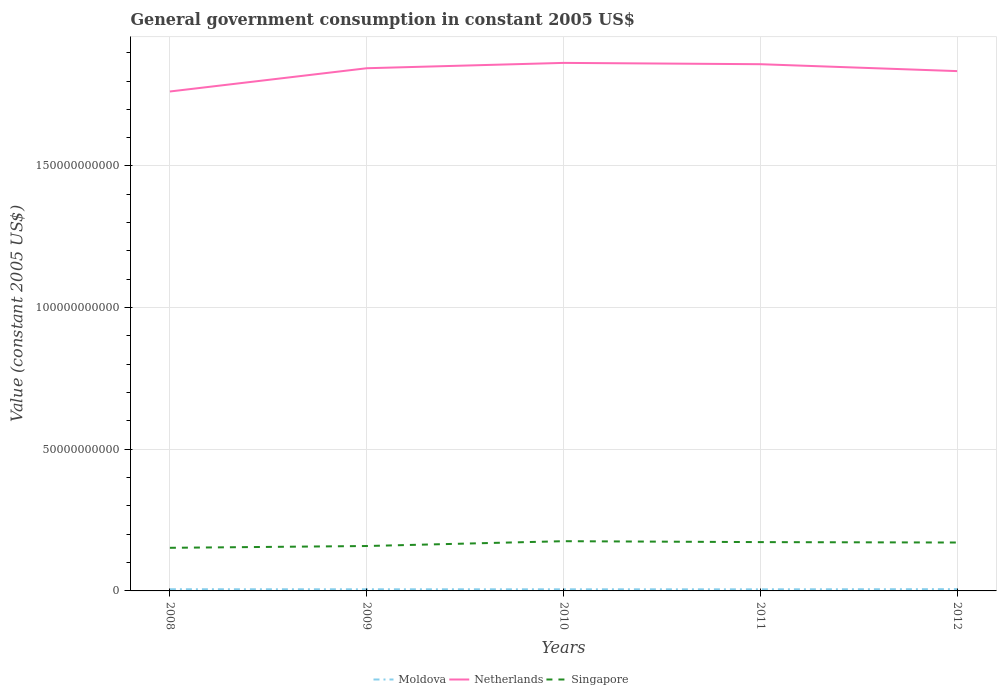Does the line corresponding to Singapore intersect with the line corresponding to Netherlands?
Your response must be concise. No. Across all years, what is the maximum government conusmption in Singapore?
Provide a short and direct response. 1.52e+1. In which year was the government conusmption in Netherlands maximum?
Provide a succinct answer. 2008. What is the total government conusmption in Netherlands in the graph?
Your answer should be compact. -1.42e+09. What is the difference between the highest and the second highest government conusmption in Singapore?
Your response must be concise. 2.34e+09. Are the values on the major ticks of Y-axis written in scientific E-notation?
Make the answer very short. No. Where does the legend appear in the graph?
Give a very brief answer. Bottom center. What is the title of the graph?
Offer a terse response. General government consumption in constant 2005 US$. Does "Costa Rica" appear as one of the legend labels in the graph?
Your answer should be very brief. No. What is the label or title of the X-axis?
Make the answer very short. Years. What is the label or title of the Y-axis?
Provide a succinct answer. Value (constant 2005 US$). What is the Value (constant 2005 US$) of Moldova in 2008?
Make the answer very short. 5.97e+08. What is the Value (constant 2005 US$) of Netherlands in 2008?
Ensure brevity in your answer.  1.76e+11. What is the Value (constant 2005 US$) of Singapore in 2008?
Give a very brief answer. 1.52e+1. What is the Value (constant 2005 US$) in Moldova in 2009?
Offer a terse response. 5.80e+08. What is the Value (constant 2005 US$) of Netherlands in 2009?
Your answer should be compact. 1.85e+11. What is the Value (constant 2005 US$) of Singapore in 2009?
Give a very brief answer. 1.59e+1. What is the Value (constant 2005 US$) in Moldova in 2010?
Your answer should be compact. 5.74e+08. What is the Value (constant 2005 US$) of Netherlands in 2010?
Your answer should be very brief. 1.86e+11. What is the Value (constant 2005 US$) of Singapore in 2010?
Your answer should be compact. 1.76e+1. What is the Value (constant 2005 US$) in Moldova in 2011?
Keep it short and to the point. 5.68e+08. What is the Value (constant 2005 US$) of Netherlands in 2011?
Offer a very short reply. 1.86e+11. What is the Value (constant 2005 US$) in Singapore in 2011?
Provide a short and direct response. 1.72e+1. What is the Value (constant 2005 US$) in Moldova in 2012?
Provide a succinct answer. 6.22e+08. What is the Value (constant 2005 US$) in Netherlands in 2012?
Make the answer very short. 1.83e+11. What is the Value (constant 2005 US$) in Singapore in 2012?
Your response must be concise. 1.71e+1. Across all years, what is the maximum Value (constant 2005 US$) in Moldova?
Give a very brief answer. 6.22e+08. Across all years, what is the maximum Value (constant 2005 US$) in Netherlands?
Your response must be concise. 1.86e+11. Across all years, what is the maximum Value (constant 2005 US$) of Singapore?
Offer a terse response. 1.76e+1. Across all years, what is the minimum Value (constant 2005 US$) of Moldova?
Provide a short and direct response. 5.68e+08. Across all years, what is the minimum Value (constant 2005 US$) of Netherlands?
Keep it short and to the point. 1.76e+11. Across all years, what is the minimum Value (constant 2005 US$) of Singapore?
Offer a terse response. 1.52e+1. What is the total Value (constant 2005 US$) of Moldova in the graph?
Your answer should be very brief. 2.94e+09. What is the total Value (constant 2005 US$) of Netherlands in the graph?
Your answer should be very brief. 9.17e+11. What is the total Value (constant 2005 US$) of Singapore in the graph?
Your response must be concise. 8.29e+1. What is the difference between the Value (constant 2005 US$) of Moldova in 2008 and that in 2009?
Your answer should be very brief. 1.71e+07. What is the difference between the Value (constant 2005 US$) of Netherlands in 2008 and that in 2009?
Make the answer very short. -8.21e+09. What is the difference between the Value (constant 2005 US$) of Singapore in 2008 and that in 2009?
Keep it short and to the point. -6.35e+08. What is the difference between the Value (constant 2005 US$) in Moldova in 2008 and that in 2010?
Your answer should be very brief. 2.33e+07. What is the difference between the Value (constant 2005 US$) in Netherlands in 2008 and that in 2010?
Your answer should be compact. -1.01e+1. What is the difference between the Value (constant 2005 US$) in Singapore in 2008 and that in 2010?
Keep it short and to the point. -2.34e+09. What is the difference between the Value (constant 2005 US$) of Moldova in 2008 and that in 2011?
Your response must be concise. 2.89e+07. What is the difference between the Value (constant 2005 US$) in Netherlands in 2008 and that in 2011?
Offer a very short reply. -9.63e+09. What is the difference between the Value (constant 2005 US$) of Singapore in 2008 and that in 2011?
Give a very brief answer. -2.01e+09. What is the difference between the Value (constant 2005 US$) of Moldova in 2008 and that in 2012?
Keep it short and to the point. -2.47e+07. What is the difference between the Value (constant 2005 US$) in Netherlands in 2008 and that in 2012?
Keep it short and to the point. -7.19e+09. What is the difference between the Value (constant 2005 US$) in Singapore in 2008 and that in 2012?
Keep it short and to the point. -1.87e+09. What is the difference between the Value (constant 2005 US$) of Moldova in 2009 and that in 2010?
Your answer should be compact. 6.27e+06. What is the difference between the Value (constant 2005 US$) in Netherlands in 2009 and that in 2010?
Provide a succinct answer. -1.89e+09. What is the difference between the Value (constant 2005 US$) in Singapore in 2009 and that in 2010?
Ensure brevity in your answer.  -1.70e+09. What is the difference between the Value (constant 2005 US$) in Moldova in 2009 and that in 2011?
Ensure brevity in your answer.  1.18e+07. What is the difference between the Value (constant 2005 US$) of Netherlands in 2009 and that in 2011?
Provide a succinct answer. -1.42e+09. What is the difference between the Value (constant 2005 US$) in Singapore in 2009 and that in 2011?
Give a very brief answer. -1.38e+09. What is the difference between the Value (constant 2005 US$) of Moldova in 2009 and that in 2012?
Your answer should be compact. -4.18e+07. What is the difference between the Value (constant 2005 US$) of Netherlands in 2009 and that in 2012?
Ensure brevity in your answer.  1.02e+09. What is the difference between the Value (constant 2005 US$) in Singapore in 2009 and that in 2012?
Make the answer very short. -1.23e+09. What is the difference between the Value (constant 2005 US$) in Moldova in 2010 and that in 2011?
Offer a very short reply. 5.57e+06. What is the difference between the Value (constant 2005 US$) in Netherlands in 2010 and that in 2011?
Provide a succinct answer. 4.61e+08. What is the difference between the Value (constant 2005 US$) of Singapore in 2010 and that in 2011?
Ensure brevity in your answer.  3.23e+08. What is the difference between the Value (constant 2005 US$) in Moldova in 2010 and that in 2012?
Provide a short and direct response. -4.81e+07. What is the difference between the Value (constant 2005 US$) of Netherlands in 2010 and that in 2012?
Your response must be concise. 2.90e+09. What is the difference between the Value (constant 2005 US$) of Singapore in 2010 and that in 2012?
Provide a succinct answer. 4.70e+08. What is the difference between the Value (constant 2005 US$) of Moldova in 2011 and that in 2012?
Provide a succinct answer. -5.37e+07. What is the difference between the Value (constant 2005 US$) of Netherlands in 2011 and that in 2012?
Make the answer very short. 2.44e+09. What is the difference between the Value (constant 2005 US$) in Singapore in 2011 and that in 2012?
Keep it short and to the point. 1.47e+08. What is the difference between the Value (constant 2005 US$) in Moldova in 2008 and the Value (constant 2005 US$) in Netherlands in 2009?
Your answer should be compact. -1.84e+11. What is the difference between the Value (constant 2005 US$) of Moldova in 2008 and the Value (constant 2005 US$) of Singapore in 2009?
Provide a short and direct response. -1.53e+1. What is the difference between the Value (constant 2005 US$) of Netherlands in 2008 and the Value (constant 2005 US$) of Singapore in 2009?
Offer a very short reply. 1.60e+11. What is the difference between the Value (constant 2005 US$) in Moldova in 2008 and the Value (constant 2005 US$) in Netherlands in 2010?
Give a very brief answer. -1.86e+11. What is the difference between the Value (constant 2005 US$) in Moldova in 2008 and the Value (constant 2005 US$) in Singapore in 2010?
Offer a very short reply. -1.70e+1. What is the difference between the Value (constant 2005 US$) in Netherlands in 2008 and the Value (constant 2005 US$) in Singapore in 2010?
Your response must be concise. 1.59e+11. What is the difference between the Value (constant 2005 US$) in Moldova in 2008 and the Value (constant 2005 US$) in Netherlands in 2011?
Give a very brief answer. -1.85e+11. What is the difference between the Value (constant 2005 US$) of Moldova in 2008 and the Value (constant 2005 US$) of Singapore in 2011?
Your response must be concise. -1.66e+1. What is the difference between the Value (constant 2005 US$) in Netherlands in 2008 and the Value (constant 2005 US$) in Singapore in 2011?
Make the answer very short. 1.59e+11. What is the difference between the Value (constant 2005 US$) of Moldova in 2008 and the Value (constant 2005 US$) of Netherlands in 2012?
Keep it short and to the point. -1.83e+11. What is the difference between the Value (constant 2005 US$) of Moldova in 2008 and the Value (constant 2005 US$) of Singapore in 2012?
Make the answer very short. -1.65e+1. What is the difference between the Value (constant 2005 US$) in Netherlands in 2008 and the Value (constant 2005 US$) in Singapore in 2012?
Offer a terse response. 1.59e+11. What is the difference between the Value (constant 2005 US$) in Moldova in 2009 and the Value (constant 2005 US$) in Netherlands in 2010?
Ensure brevity in your answer.  -1.86e+11. What is the difference between the Value (constant 2005 US$) in Moldova in 2009 and the Value (constant 2005 US$) in Singapore in 2010?
Keep it short and to the point. -1.70e+1. What is the difference between the Value (constant 2005 US$) in Netherlands in 2009 and the Value (constant 2005 US$) in Singapore in 2010?
Provide a succinct answer. 1.67e+11. What is the difference between the Value (constant 2005 US$) in Moldova in 2009 and the Value (constant 2005 US$) in Netherlands in 2011?
Provide a short and direct response. -1.85e+11. What is the difference between the Value (constant 2005 US$) of Moldova in 2009 and the Value (constant 2005 US$) of Singapore in 2011?
Provide a succinct answer. -1.67e+1. What is the difference between the Value (constant 2005 US$) of Netherlands in 2009 and the Value (constant 2005 US$) of Singapore in 2011?
Make the answer very short. 1.67e+11. What is the difference between the Value (constant 2005 US$) in Moldova in 2009 and the Value (constant 2005 US$) in Netherlands in 2012?
Provide a short and direct response. -1.83e+11. What is the difference between the Value (constant 2005 US$) in Moldova in 2009 and the Value (constant 2005 US$) in Singapore in 2012?
Ensure brevity in your answer.  -1.65e+1. What is the difference between the Value (constant 2005 US$) in Netherlands in 2009 and the Value (constant 2005 US$) in Singapore in 2012?
Make the answer very short. 1.67e+11. What is the difference between the Value (constant 2005 US$) of Moldova in 2010 and the Value (constant 2005 US$) of Netherlands in 2011?
Your answer should be very brief. -1.85e+11. What is the difference between the Value (constant 2005 US$) of Moldova in 2010 and the Value (constant 2005 US$) of Singapore in 2011?
Give a very brief answer. -1.67e+1. What is the difference between the Value (constant 2005 US$) of Netherlands in 2010 and the Value (constant 2005 US$) of Singapore in 2011?
Offer a terse response. 1.69e+11. What is the difference between the Value (constant 2005 US$) in Moldova in 2010 and the Value (constant 2005 US$) in Netherlands in 2012?
Your answer should be very brief. -1.83e+11. What is the difference between the Value (constant 2005 US$) in Moldova in 2010 and the Value (constant 2005 US$) in Singapore in 2012?
Make the answer very short. -1.65e+1. What is the difference between the Value (constant 2005 US$) in Netherlands in 2010 and the Value (constant 2005 US$) in Singapore in 2012?
Ensure brevity in your answer.  1.69e+11. What is the difference between the Value (constant 2005 US$) in Moldova in 2011 and the Value (constant 2005 US$) in Netherlands in 2012?
Offer a very short reply. -1.83e+11. What is the difference between the Value (constant 2005 US$) of Moldova in 2011 and the Value (constant 2005 US$) of Singapore in 2012?
Give a very brief answer. -1.65e+1. What is the difference between the Value (constant 2005 US$) in Netherlands in 2011 and the Value (constant 2005 US$) in Singapore in 2012?
Provide a short and direct response. 1.69e+11. What is the average Value (constant 2005 US$) in Moldova per year?
Keep it short and to the point. 5.88e+08. What is the average Value (constant 2005 US$) of Netherlands per year?
Give a very brief answer. 1.83e+11. What is the average Value (constant 2005 US$) in Singapore per year?
Keep it short and to the point. 1.66e+1. In the year 2008, what is the difference between the Value (constant 2005 US$) of Moldova and Value (constant 2005 US$) of Netherlands?
Ensure brevity in your answer.  -1.76e+11. In the year 2008, what is the difference between the Value (constant 2005 US$) of Moldova and Value (constant 2005 US$) of Singapore?
Ensure brevity in your answer.  -1.46e+1. In the year 2008, what is the difference between the Value (constant 2005 US$) of Netherlands and Value (constant 2005 US$) of Singapore?
Your response must be concise. 1.61e+11. In the year 2009, what is the difference between the Value (constant 2005 US$) of Moldova and Value (constant 2005 US$) of Netherlands?
Give a very brief answer. -1.84e+11. In the year 2009, what is the difference between the Value (constant 2005 US$) of Moldova and Value (constant 2005 US$) of Singapore?
Make the answer very short. -1.53e+1. In the year 2009, what is the difference between the Value (constant 2005 US$) of Netherlands and Value (constant 2005 US$) of Singapore?
Provide a succinct answer. 1.69e+11. In the year 2010, what is the difference between the Value (constant 2005 US$) of Moldova and Value (constant 2005 US$) of Netherlands?
Make the answer very short. -1.86e+11. In the year 2010, what is the difference between the Value (constant 2005 US$) of Moldova and Value (constant 2005 US$) of Singapore?
Your answer should be compact. -1.70e+1. In the year 2010, what is the difference between the Value (constant 2005 US$) in Netherlands and Value (constant 2005 US$) in Singapore?
Your response must be concise. 1.69e+11. In the year 2011, what is the difference between the Value (constant 2005 US$) of Moldova and Value (constant 2005 US$) of Netherlands?
Make the answer very short. -1.85e+11. In the year 2011, what is the difference between the Value (constant 2005 US$) of Moldova and Value (constant 2005 US$) of Singapore?
Offer a very short reply. -1.67e+1. In the year 2011, what is the difference between the Value (constant 2005 US$) in Netherlands and Value (constant 2005 US$) in Singapore?
Provide a succinct answer. 1.69e+11. In the year 2012, what is the difference between the Value (constant 2005 US$) of Moldova and Value (constant 2005 US$) of Netherlands?
Your answer should be very brief. -1.83e+11. In the year 2012, what is the difference between the Value (constant 2005 US$) in Moldova and Value (constant 2005 US$) in Singapore?
Provide a short and direct response. -1.65e+1. In the year 2012, what is the difference between the Value (constant 2005 US$) in Netherlands and Value (constant 2005 US$) in Singapore?
Provide a succinct answer. 1.66e+11. What is the ratio of the Value (constant 2005 US$) in Moldova in 2008 to that in 2009?
Your response must be concise. 1.03. What is the ratio of the Value (constant 2005 US$) in Netherlands in 2008 to that in 2009?
Make the answer very short. 0.96. What is the ratio of the Value (constant 2005 US$) in Moldova in 2008 to that in 2010?
Provide a succinct answer. 1.04. What is the ratio of the Value (constant 2005 US$) in Netherlands in 2008 to that in 2010?
Keep it short and to the point. 0.95. What is the ratio of the Value (constant 2005 US$) of Singapore in 2008 to that in 2010?
Your answer should be very brief. 0.87. What is the ratio of the Value (constant 2005 US$) of Moldova in 2008 to that in 2011?
Ensure brevity in your answer.  1.05. What is the ratio of the Value (constant 2005 US$) of Netherlands in 2008 to that in 2011?
Your answer should be very brief. 0.95. What is the ratio of the Value (constant 2005 US$) of Singapore in 2008 to that in 2011?
Give a very brief answer. 0.88. What is the ratio of the Value (constant 2005 US$) of Moldova in 2008 to that in 2012?
Make the answer very short. 0.96. What is the ratio of the Value (constant 2005 US$) of Netherlands in 2008 to that in 2012?
Your answer should be compact. 0.96. What is the ratio of the Value (constant 2005 US$) of Singapore in 2008 to that in 2012?
Make the answer very short. 0.89. What is the ratio of the Value (constant 2005 US$) of Moldova in 2009 to that in 2010?
Give a very brief answer. 1.01. What is the ratio of the Value (constant 2005 US$) of Singapore in 2009 to that in 2010?
Your answer should be compact. 0.9. What is the ratio of the Value (constant 2005 US$) in Moldova in 2009 to that in 2011?
Your response must be concise. 1.02. What is the ratio of the Value (constant 2005 US$) of Moldova in 2009 to that in 2012?
Your answer should be very brief. 0.93. What is the ratio of the Value (constant 2005 US$) in Singapore in 2009 to that in 2012?
Offer a very short reply. 0.93. What is the ratio of the Value (constant 2005 US$) of Moldova in 2010 to that in 2011?
Offer a very short reply. 1.01. What is the ratio of the Value (constant 2005 US$) in Netherlands in 2010 to that in 2011?
Your answer should be very brief. 1. What is the ratio of the Value (constant 2005 US$) in Singapore in 2010 to that in 2011?
Make the answer very short. 1.02. What is the ratio of the Value (constant 2005 US$) in Moldova in 2010 to that in 2012?
Your response must be concise. 0.92. What is the ratio of the Value (constant 2005 US$) of Netherlands in 2010 to that in 2012?
Ensure brevity in your answer.  1.02. What is the ratio of the Value (constant 2005 US$) in Singapore in 2010 to that in 2012?
Make the answer very short. 1.03. What is the ratio of the Value (constant 2005 US$) in Moldova in 2011 to that in 2012?
Give a very brief answer. 0.91. What is the ratio of the Value (constant 2005 US$) of Netherlands in 2011 to that in 2012?
Provide a short and direct response. 1.01. What is the ratio of the Value (constant 2005 US$) of Singapore in 2011 to that in 2012?
Your response must be concise. 1.01. What is the difference between the highest and the second highest Value (constant 2005 US$) in Moldova?
Provide a short and direct response. 2.47e+07. What is the difference between the highest and the second highest Value (constant 2005 US$) of Netherlands?
Give a very brief answer. 4.61e+08. What is the difference between the highest and the second highest Value (constant 2005 US$) in Singapore?
Make the answer very short. 3.23e+08. What is the difference between the highest and the lowest Value (constant 2005 US$) of Moldova?
Make the answer very short. 5.37e+07. What is the difference between the highest and the lowest Value (constant 2005 US$) in Netherlands?
Your response must be concise. 1.01e+1. What is the difference between the highest and the lowest Value (constant 2005 US$) of Singapore?
Your response must be concise. 2.34e+09. 